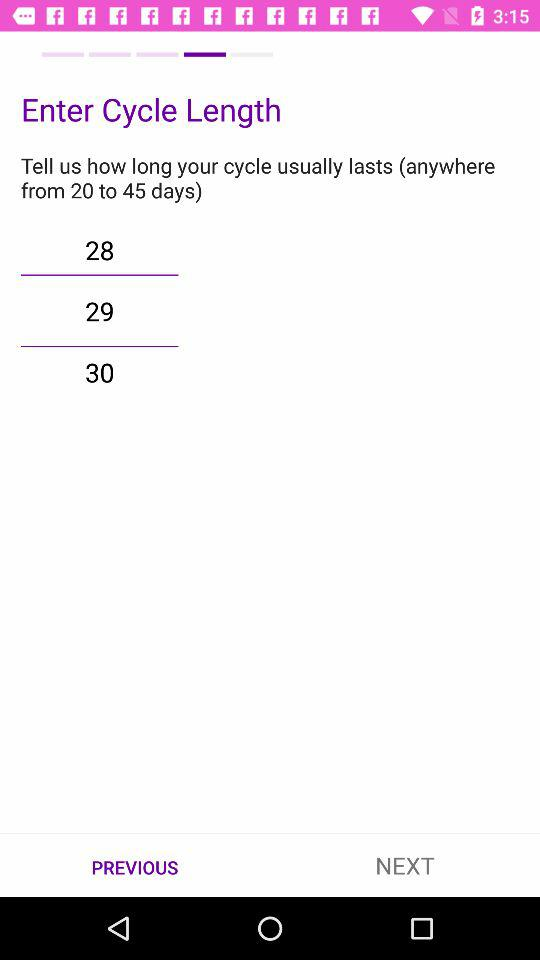How many days are there between the minimum and maximum cycle length?
Answer the question using a single word or phrase. 25 